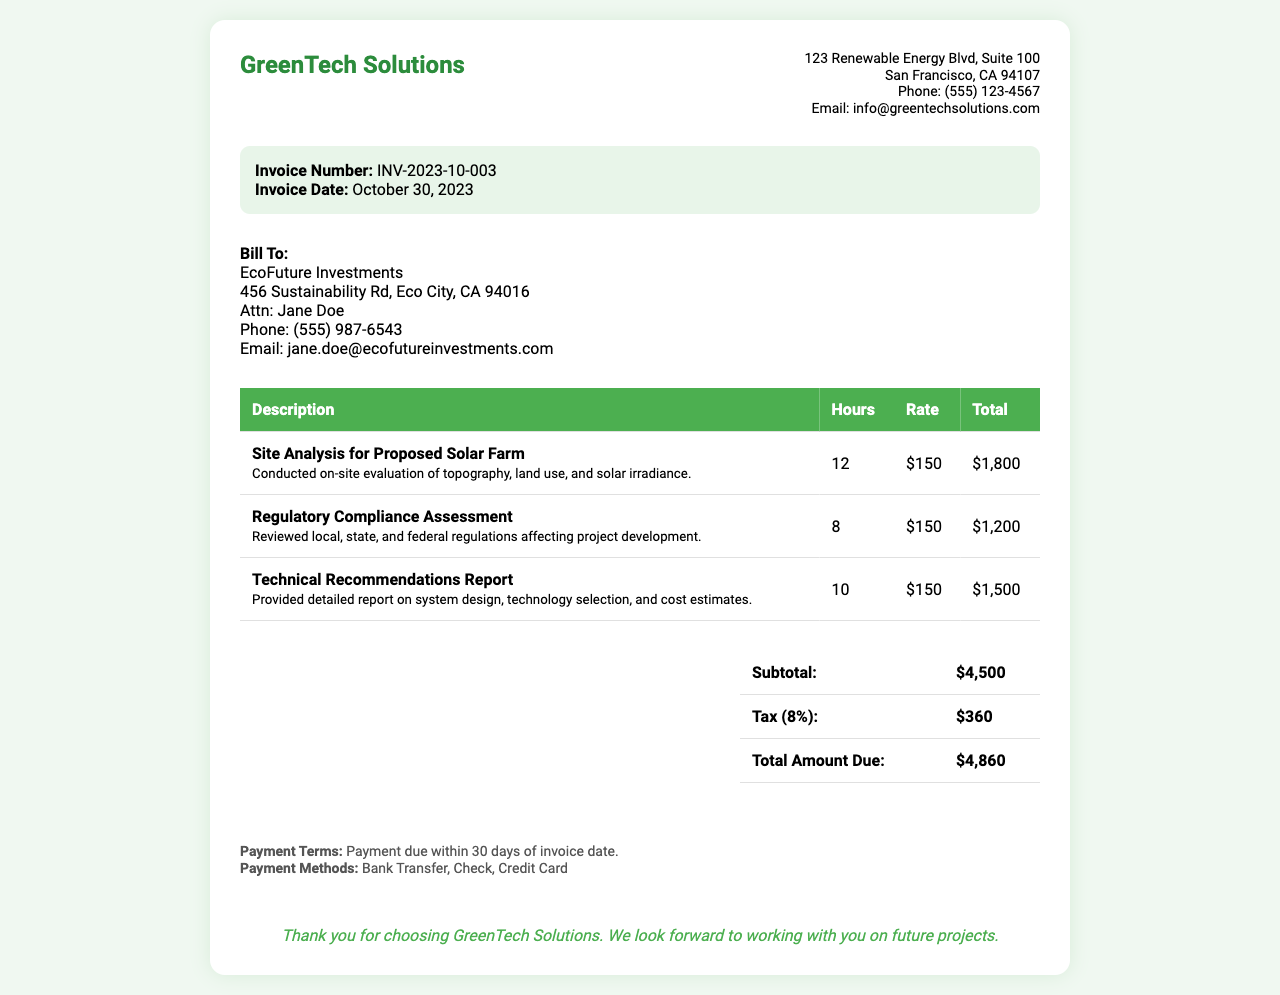what is the invoice number? The invoice number is clearly stated in the document to identify the specific transaction, which is INV-2023-10-003.
Answer: INV-2023-10-003 who is the bill recipient? The document specifies the organization billed for services, which is EcoFuture Investments.
Answer: EcoFuture Investments how many hours were spent on site analysis? The hours spent on site analysis are detailed in the invoice, listing a total of 12 hours.
Answer: 12 what is the total amount due? The total amount due is calculated at the end of the invoice, which is $4,860.
Answer: $4,860 which service received the highest charge? By comparing the totals for each service, the one with the highest charge is site analysis at $1,800.
Answer: Site Analysis for Proposed Solar Farm how much tax is applied to the invoice? The tax amount is shown in the summary section of the invoice, totaling $360.
Answer: $360 what is the payment term? The invoice specifies the payment term as due within 30 days of the invoice date.
Answer: 30 days what is the contact email for the company? The document provides contact information, including the company's email, which is info@greentechsolutions.com.
Answer: info@greentechsolutions.com how many total services are listed in the invoice? The invoice lists a total of three distinct services provided.
Answer: Three 